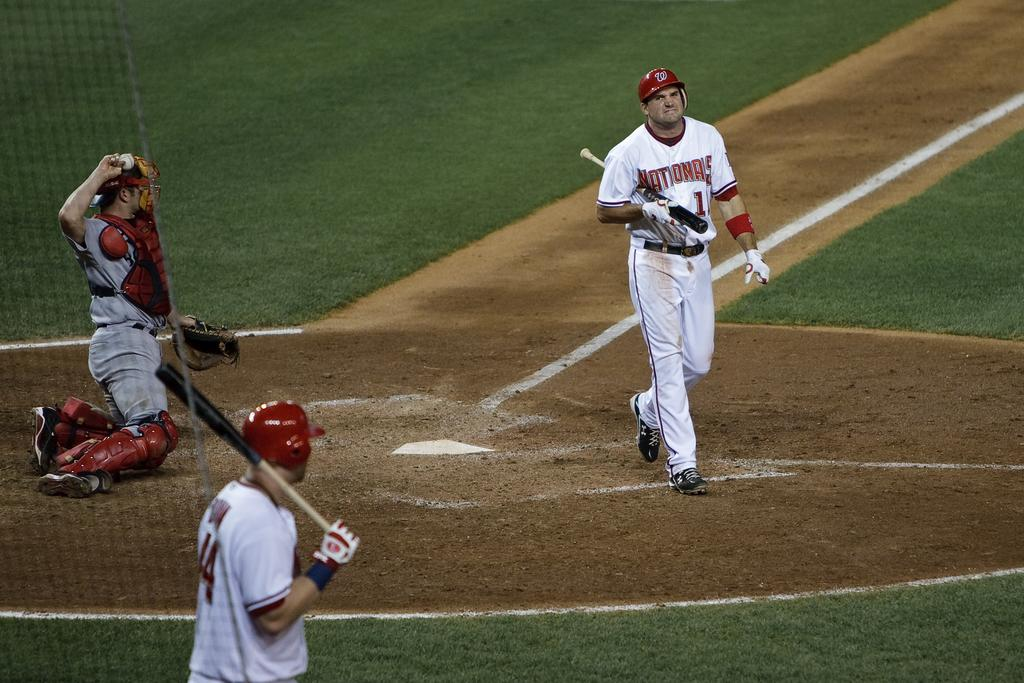<image>
Create a compact narrative representing the image presented. A man in a Nationals jersey holds a baseball bat under his arm. 